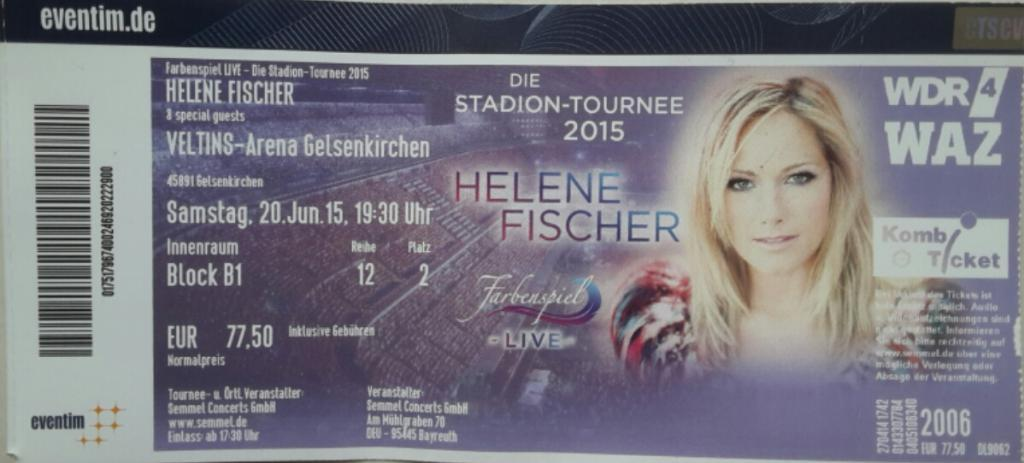What is the main subject of the image? The main subject of the image is a lady's face. Are there any words or letters in the image? Yes, there is some text in the image. How many cakes are being driven through the dirt in the image? There are no cakes or cars present in the image; it features a lady's face and some text. 